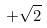Convert formula to latex. <formula><loc_0><loc_0><loc_500><loc_500>+ \sqrt { 2 }</formula> 